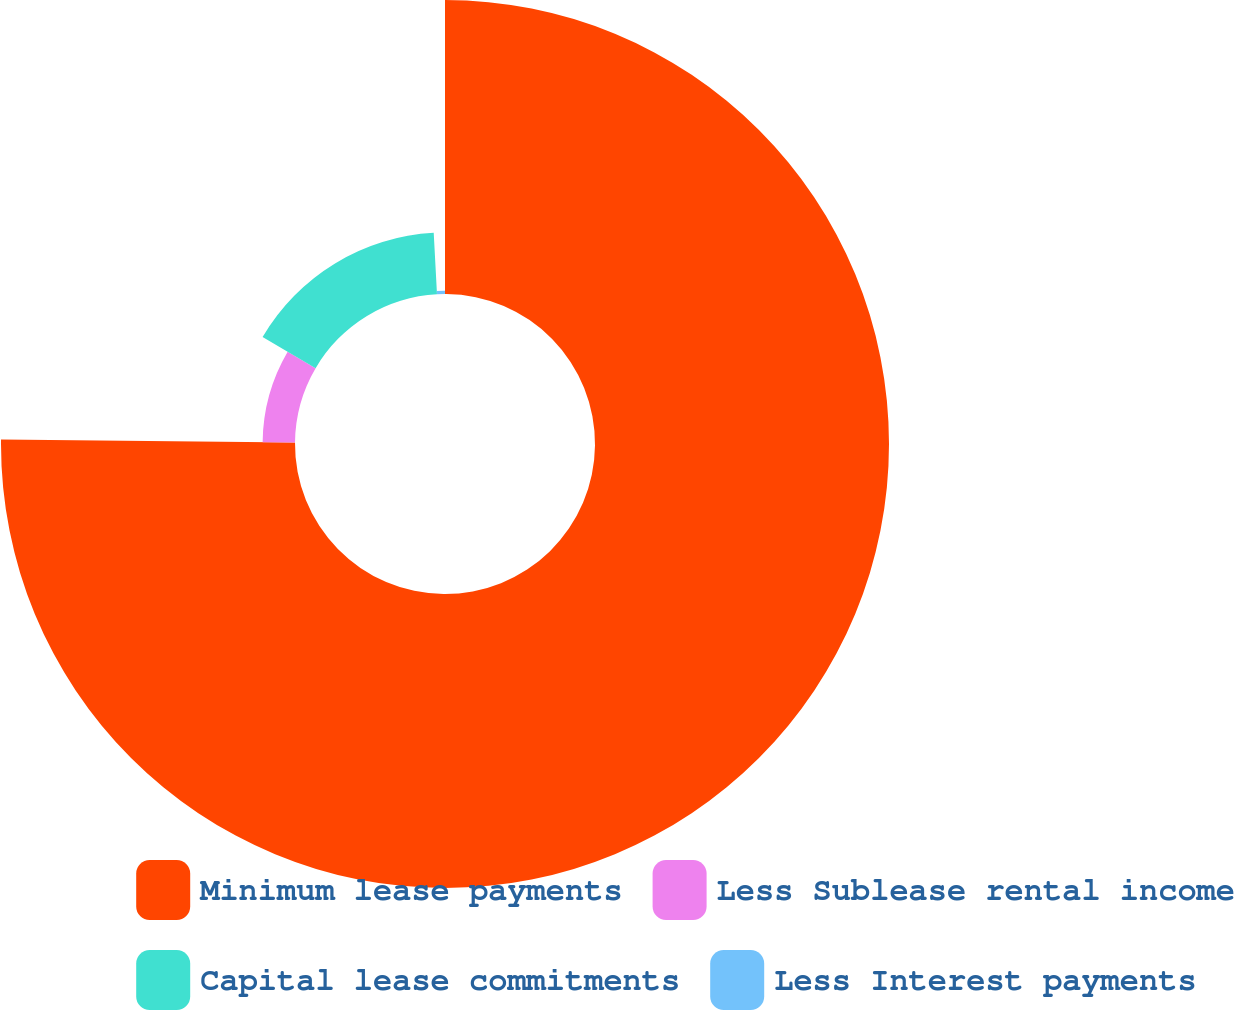Convert chart. <chart><loc_0><loc_0><loc_500><loc_500><pie_chart><fcel>Minimum lease payments<fcel>Less Sublease rental income<fcel>Capital lease commitments<fcel>Less Interest payments<nl><fcel>75.16%<fcel>8.28%<fcel>15.71%<fcel>0.85%<nl></chart> 